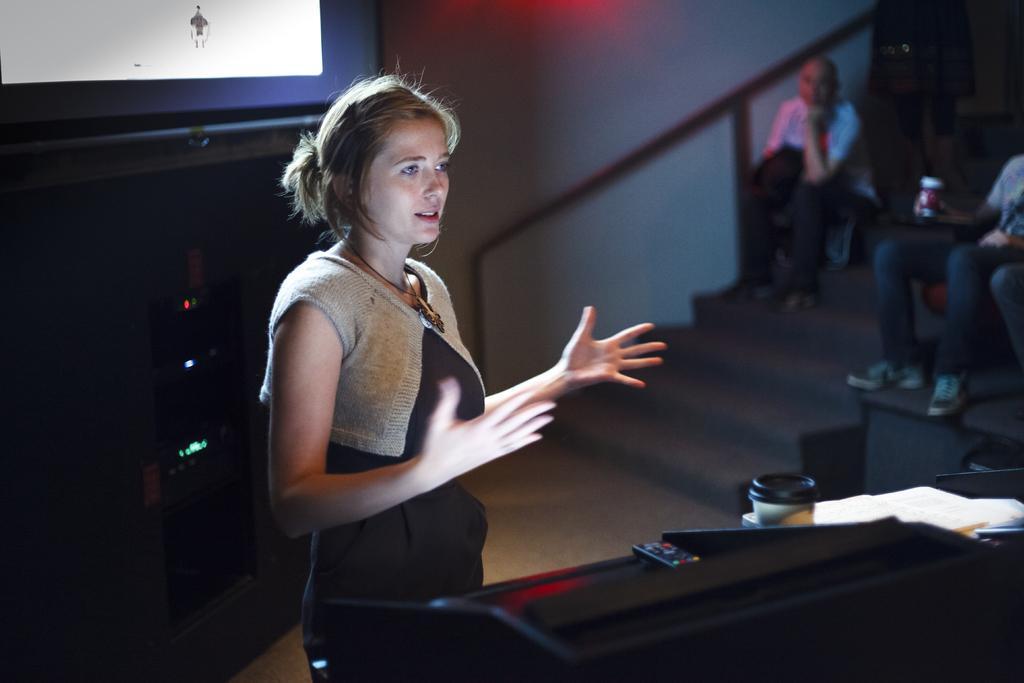Could you give a brief overview of what you see in this image? In this picture there is a woman standing and there is a remote,books and some other objects in front of her and there are two persons sitting in the right corner and there is a projected image in the left top corner. 